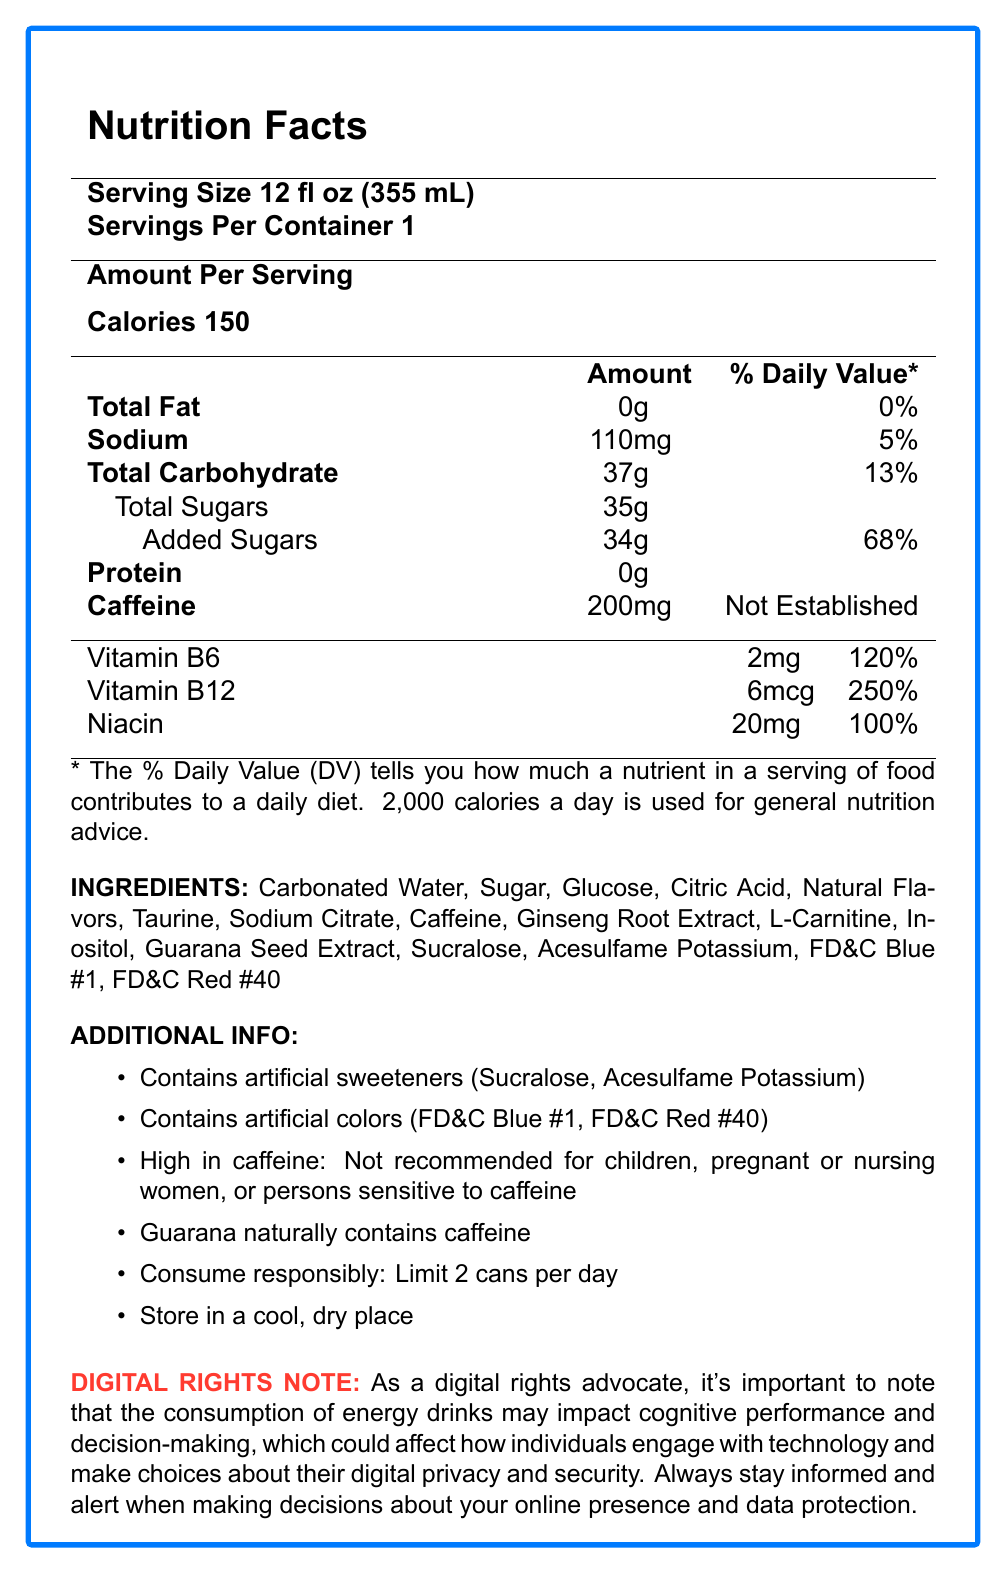how many servings are there per container of TechBoost Energy? According to the document, the serving size is 12 fl oz (355 mL) and there is 1 serving per container.
Answer: 1 how much caffeine is in a serving of TechBoost Energy? The document states that there are 200mg of caffeine per serving.
Answer: 200mg is TechBoost Energy recommended for children? The additional info mentions that it is not recommended for children due to its high caffeine content.
Answer: No what are the artificial sweeteners listed in TechBoost Energy? According to the ingredients list, the artificial sweeteners included are Sucralose and Acesulfame Potassium.
Answer: Sucralose, Acesulfame Potassium what is the percentage daily value of Vitamin B6 in TechBoost Energy? The nutrition facts section states that Vitamin B6 has a daily value percentage of 120%.
Answer: 120% which of the following is not a vitamin or mineral in TechBoost Energy? A. Vitamin B6 B. Vitamin B12 C. Niacin D. Vitamin C The mentioned vitamins and minerals include Vitamin B6, Vitamin B12, and Niacin, but not Vitamin C.
Answer: D which ingredient is responsible for the red color in TechBoost Energy? A. FD&C Blue #1 B. FD&C Red #40 C. Sucralose D. Inositol FD&C Red #40 is listed as the artificial color responsible for the red color.
Answer: B does the document state that TechBoost Energy contains natural flavors? It is mentioned in the ingredients list that TechBoost Energy contains natural flavors.
Answer: Yes summarize the key details of the TechBoost Energy nutrition facts and additional info. This is a summary of the primary nutritional components and the critical additional information provided in the document.
Answer: TechBoost Energy is an energy drink with 150 calories per 12 fl oz serving. It contains 200mg of caffeine, 37g of carbohydrates, 35g of sugar (34g of which are added sugars), and zero fat and protein. It has vitamins B6, B12, and Niacin. The drink includes artificial sweeteners (Sucralose, Acesulfame Potassium) and artificial colors (FD&C Blue #1, FD&C Red #40). High in caffeine, it is not recommended for children, pregnant or nursing women, or persons sensitive to caffeine. Consumers are advised to limit intake to 2 cans per day. how does the caffeine content affect tech professionals' decision-making? The document does not provide specific details on how the caffeine content in TechBoost Energy affects tech professionals' decision-making, just a general digital rights note about cognitive performance and decision-making.
Answer: Not enough information 